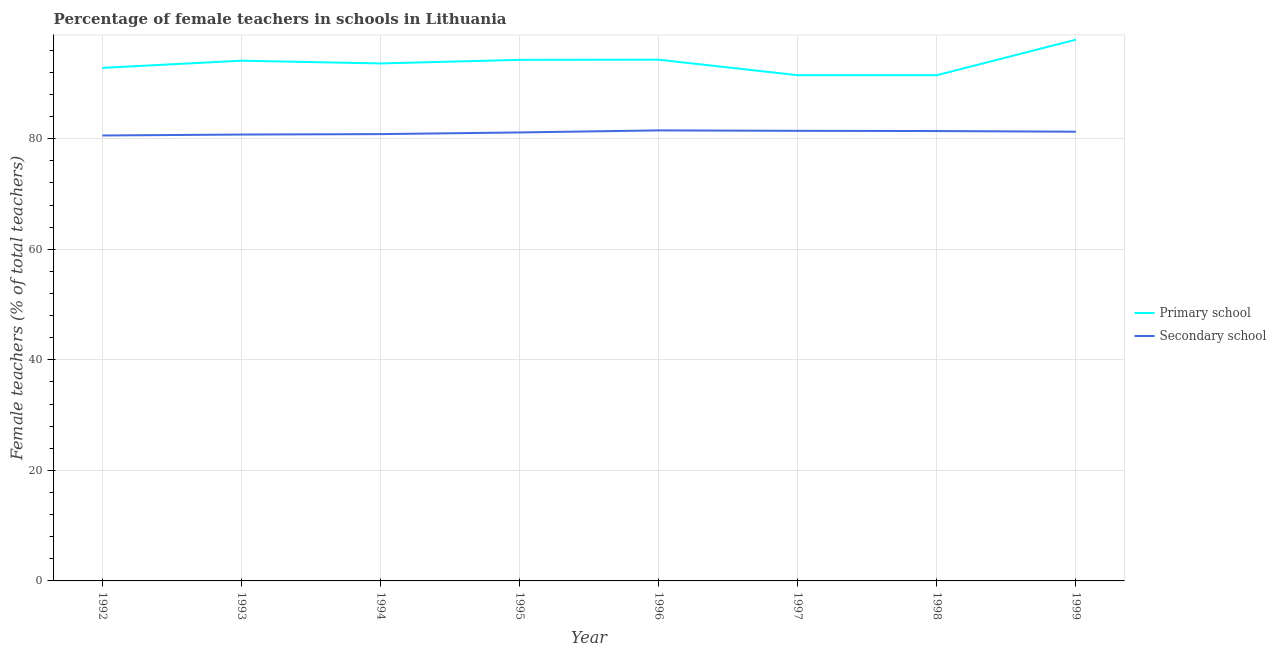How many different coloured lines are there?
Make the answer very short. 2. What is the percentage of female teachers in primary schools in 1994?
Provide a short and direct response. 93.61. Across all years, what is the maximum percentage of female teachers in primary schools?
Offer a terse response. 97.91. Across all years, what is the minimum percentage of female teachers in secondary schools?
Give a very brief answer. 80.58. In which year was the percentage of female teachers in secondary schools maximum?
Make the answer very short. 1996. In which year was the percentage of female teachers in primary schools minimum?
Give a very brief answer. 1997. What is the total percentage of female teachers in primary schools in the graph?
Keep it short and to the point. 749.98. What is the difference between the percentage of female teachers in primary schools in 1996 and that in 1998?
Offer a very short reply. 2.8. What is the difference between the percentage of female teachers in secondary schools in 1999 and the percentage of female teachers in primary schools in 1995?
Make the answer very short. -13. What is the average percentage of female teachers in secondary schools per year?
Your answer should be very brief. 81.11. In the year 1994, what is the difference between the percentage of female teachers in primary schools and percentage of female teachers in secondary schools?
Your answer should be compact. 12.78. What is the ratio of the percentage of female teachers in primary schools in 1992 to that in 1999?
Offer a very short reply. 0.95. What is the difference between the highest and the second highest percentage of female teachers in primary schools?
Provide a short and direct response. 3.62. What is the difference between the highest and the lowest percentage of female teachers in secondary schools?
Give a very brief answer. 0.92. Is the sum of the percentage of female teachers in secondary schools in 1992 and 1998 greater than the maximum percentage of female teachers in primary schools across all years?
Your answer should be very brief. Yes. Does the percentage of female teachers in primary schools monotonically increase over the years?
Provide a succinct answer. No. Is the percentage of female teachers in primary schools strictly less than the percentage of female teachers in secondary schools over the years?
Offer a very short reply. No. How many lines are there?
Ensure brevity in your answer.  2. How many years are there in the graph?
Offer a terse response. 8. What is the difference between two consecutive major ticks on the Y-axis?
Give a very brief answer. 20. Are the values on the major ticks of Y-axis written in scientific E-notation?
Give a very brief answer. No. Does the graph contain any zero values?
Your answer should be compact. No. How are the legend labels stacked?
Offer a very short reply. Vertical. What is the title of the graph?
Give a very brief answer. Percentage of female teachers in schools in Lithuania. Does "Export" appear as one of the legend labels in the graph?
Your answer should be compact. No. What is the label or title of the X-axis?
Keep it short and to the point. Year. What is the label or title of the Y-axis?
Keep it short and to the point. Female teachers (% of total teachers). What is the Female teachers (% of total teachers) in Primary school in 1992?
Your response must be concise. 92.81. What is the Female teachers (% of total teachers) of Secondary school in 1992?
Provide a short and direct response. 80.58. What is the Female teachers (% of total teachers) of Primary school in 1993?
Give a very brief answer. 94.11. What is the Female teachers (% of total teachers) in Secondary school in 1993?
Your answer should be compact. 80.75. What is the Female teachers (% of total teachers) in Primary school in 1994?
Ensure brevity in your answer.  93.61. What is the Female teachers (% of total teachers) in Secondary school in 1994?
Give a very brief answer. 80.83. What is the Female teachers (% of total teachers) in Primary school in 1995?
Your answer should be compact. 94.27. What is the Female teachers (% of total teachers) of Secondary school in 1995?
Give a very brief answer. 81.13. What is the Female teachers (% of total teachers) of Primary school in 1996?
Provide a succinct answer. 94.29. What is the Female teachers (% of total teachers) of Secondary school in 1996?
Your answer should be very brief. 81.5. What is the Female teachers (% of total teachers) of Primary school in 1997?
Your answer should be very brief. 91.49. What is the Female teachers (% of total teachers) of Secondary school in 1997?
Provide a short and direct response. 81.42. What is the Female teachers (% of total teachers) in Primary school in 1998?
Your response must be concise. 91.49. What is the Female teachers (% of total teachers) of Secondary school in 1998?
Your answer should be compact. 81.38. What is the Female teachers (% of total teachers) in Primary school in 1999?
Provide a short and direct response. 97.91. What is the Female teachers (% of total teachers) of Secondary school in 1999?
Offer a very short reply. 81.26. Across all years, what is the maximum Female teachers (% of total teachers) of Primary school?
Your answer should be compact. 97.91. Across all years, what is the maximum Female teachers (% of total teachers) in Secondary school?
Ensure brevity in your answer.  81.5. Across all years, what is the minimum Female teachers (% of total teachers) in Primary school?
Provide a short and direct response. 91.49. Across all years, what is the minimum Female teachers (% of total teachers) in Secondary school?
Make the answer very short. 80.58. What is the total Female teachers (% of total teachers) in Primary school in the graph?
Give a very brief answer. 749.98. What is the total Female teachers (% of total teachers) in Secondary school in the graph?
Ensure brevity in your answer.  648.87. What is the difference between the Female teachers (% of total teachers) of Primary school in 1992 and that in 1993?
Keep it short and to the point. -1.3. What is the difference between the Female teachers (% of total teachers) of Secondary school in 1992 and that in 1993?
Keep it short and to the point. -0.17. What is the difference between the Female teachers (% of total teachers) of Primary school in 1992 and that in 1994?
Make the answer very short. -0.8. What is the difference between the Female teachers (% of total teachers) in Secondary school in 1992 and that in 1994?
Your answer should be very brief. -0.25. What is the difference between the Female teachers (% of total teachers) in Primary school in 1992 and that in 1995?
Keep it short and to the point. -1.45. What is the difference between the Female teachers (% of total teachers) of Secondary school in 1992 and that in 1995?
Give a very brief answer. -0.55. What is the difference between the Female teachers (% of total teachers) in Primary school in 1992 and that in 1996?
Provide a short and direct response. -1.48. What is the difference between the Female teachers (% of total teachers) in Secondary school in 1992 and that in 1996?
Provide a short and direct response. -0.92. What is the difference between the Female teachers (% of total teachers) of Primary school in 1992 and that in 1997?
Give a very brief answer. 1.32. What is the difference between the Female teachers (% of total teachers) in Secondary school in 1992 and that in 1997?
Keep it short and to the point. -0.84. What is the difference between the Female teachers (% of total teachers) of Primary school in 1992 and that in 1998?
Ensure brevity in your answer.  1.32. What is the difference between the Female teachers (% of total teachers) of Secondary school in 1992 and that in 1998?
Your answer should be very brief. -0.8. What is the difference between the Female teachers (% of total teachers) in Primary school in 1992 and that in 1999?
Offer a very short reply. -5.1. What is the difference between the Female teachers (% of total teachers) of Secondary school in 1992 and that in 1999?
Your answer should be compact. -0.68. What is the difference between the Female teachers (% of total teachers) in Primary school in 1993 and that in 1994?
Provide a short and direct response. 0.5. What is the difference between the Female teachers (% of total teachers) of Secondary school in 1993 and that in 1994?
Your response must be concise. -0.08. What is the difference between the Female teachers (% of total teachers) of Primary school in 1993 and that in 1995?
Give a very brief answer. -0.15. What is the difference between the Female teachers (% of total teachers) of Secondary school in 1993 and that in 1995?
Offer a very short reply. -0.38. What is the difference between the Female teachers (% of total teachers) in Primary school in 1993 and that in 1996?
Offer a terse response. -0.18. What is the difference between the Female teachers (% of total teachers) of Secondary school in 1993 and that in 1996?
Provide a short and direct response. -0.75. What is the difference between the Female teachers (% of total teachers) of Primary school in 1993 and that in 1997?
Keep it short and to the point. 2.63. What is the difference between the Female teachers (% of total teachers) of Secondary school in 1993 and that in 1997?
Your answer should be compact. -0.67. What is the difference between the Female teachers (% of total teachers) of Primary school in 1993 and that in 1998?
Your answer should be compact. 2.63. What is the difference between the Female teachers (% of total teachers) in Secondary school in 1993 and that in 1998?
Provide a short and direct response. -0.63. What is the difference between the Female teachers (% of total teachers) of Primary school in 1993 and that in 1999?
Ensure brevity in your answer.  -3.8. What is the difference between the Female teachers (% of total teachers) of Secondary school in 1993 and that in 1999?
Offer a terse response. -0.51. What is the difference between the Female teachers (% of total teachers) in Primary school in 1994 and that in 1995?
Keep it short and to the point. -0.65. What is the difference between the Female teachers (% of total teachers) of Secondary school in 1994 and that in 1995?
Give a very brief answer. -0.3. What is the difference between the Female teachers (% of total teachers) of Primary school in 1994 and that in 1996?
Your answer should be very brief. -0.68. What is the difference between the Female teachers (% of total teachers) in Secondary school in 1994 and that in 1996?
Your answer should be compact. -0.67. What is the difference between the Female teachers (% of total teachers) of Primary school in 1994 and that in 1997?
Provide a short and direct response. 2.12. What is the difference between the Female teachers (% of total teachers) in Secondary school in 1994 and that in 1997?
Make the answer very short. -0.59. What is the difference between the Female teachers (% of total teachers) in Primary school in 1994 and that in 1998?
Make the answer very short. 2.12. What is the difference between the Female teachers (% of total teachers) in Secondary school in 1994 and that in 1998?
Provide a short and direct response. -0.56. What is the difference between the Female teachers (% of total teachers) of Primary school in 1994 and that in 1999?
Your answer should be very brief. -4.3. What is the difference between the Female teachers (% of total teachers) in Secondary school in 1994 and that in 1999?
Your answer should be very brief. -0.44. What is the difference between the Female teachers (% of total teachers) of Primary school in 1995 and that in 1996?
Offer a very short reply. -0.03. What is the difference between the Female teachers (% of total teachers) in Secondary school in 1995 and that in 1996?
Keep it short and to the point. -0.37. What is the difference between the Female teachers (% of total teachers) in Primary school in 1995 and that in 1997?
Offer a very short reply. 2.78. What is the difference between the Female teachers (% of total teachers) of Secondary school in 1995 and that in 1997?
Your answer should be very brief. -0.29. What is the difference between the Female teachers (% of total teachers) of Primary school in 1995 and that in 1998?
Provide a succinct answer. 2.78. What is the difference between the Female teachers (% of total teachers) in Secondary school in 1995 and that in 1998?
Provide a short and direct response. -0.25. What is the difference between the Female teachers (% of total teachers) of Primary school in 1995 and that in 1999?
Keep it short and to the point. -3.65. What is the difference between the Female teachers (% of total teachers) in Secondary school in 1995 and that in 1999?
Your answer should be very brief. -0.13. What is the difference between the Female teachers (% of total teachers) in Primary school in 1996 and that in 1997?
Provide a short and direct response. 2.8. What is the difference between the Female teachers (% of total teachers) of Secondary school in 1996 and that in 1997?
Give a very brief answer. 0.08. What is the difference between the Female teachers (% of total teachers) in Primary school in 1996 and that in 1998?
Provide a short and direct response. 2.8. What is the difference between the Female teachers (% of total teachers) in Secondary school in 1996 and that in 1998?
Your response must be concise. 0.12. What is the difference between the Female teachers (% of total teachers) in Primary school in 1996 and that in 1999?
Provide a short and direct response. -3.62. What is the difference between the Female teachers (% of total teachers) of Secondary school in 1996 and that in 1999?
Offer a terse response. 0.24. What is the difference between the Female teachers (% of total teachers) of Primary school in 1997 and that in 1998?
Offer a terse response. -0. What is the difference between the Female teachers (% of total teachers) in Secondary school in 1997 and that in 1998?
Ensure brevity in your answer.  0.04. What is the difference between the Female teachers (% of total teachers) of Primary school in 1997 and that in 1999?
Keep it short and to the point. -6.43. What is the difference between the Female teachers (% of total teachers) in Secondary school in 1997 and that in 1999?
Your response must be concise. 0.16. What is the difference between the Female teachers (% of total teachers) of Primary school in 1998 and that in 1999?
Keep it short and to the point. -6.43. What is the difference between the Female teachers (% of total teachers) in Secondary school in 1998 and that in 1999?
Your answer should be very brief. 0.12. What is the difference between the Female teachers (% of total teachers) of Primary school in 1992 and the Female teachers (% of total teachers) of Secondary school in 1993?
Ensure brevity in your answer.  12.06. What is the difference between the Female teachers (% of total teachers) in Primary school in 1992 and the Female teachers (% of total teachers) in Secondary school in 1994?
Provide a succinct answer. 11.98. What is the difference between the Female teachers (% of total teachers) of Primary school in 1992 and the Female teachers (% of total teachers) of Secondary school in 1995?
Keep it short and to the point. 11.68. What is the difference between the Female teachers (% of total teachers) of Primary school in 1992 and the Female teachers (% of total teachers) of Secondary school in 1996?
Keep it short and to the point. 11.31. What is the difference between the Female teachers (% of total teachers) in Primary school in 1992 and the Female teachers (% of total teachers) in Secondary school in 1997?
Provide a short and direct response. 11.39. What is the difference between the Female teachers (% of total teachers) in Primary school in 1992 and the Female teachers (% of total teachers) in Secondary school in 1998?
Provide a succinct answer. 11.43. What is the difference between the Female teachers (% of total teachers) of Primary school in 1992 and the Female teachers (% of total teachers) of Secondary school in 1999?
Provide a short and direct response. 11.55. What is the difference between the Female teachers (% of total teachers) of Primary school in 1993 and the Female teachers (% of total teachers) of Secondary school in 1994?
Your response must be concise. 13.28. What is the difference between the Female teachers (% of total teachers) in Primary school in 1993 and the Female teachers (% of total teachers) in Secondary school in 1995?
Ensure brevity in your answer.  12.98. What is the difference between the Female teachers (% of total teachers) in Primary school in 1993 and the Female teachers (% of total teachers) in Secondary school in 1996?
Keep it short and to the point. 12.61. What is the difference between the Female teachers (% of total teachers) of Primary school in 1993 and the Female teachers (% of total teachers) of Secondary school in 1997?
Make the answer very short. 12.69. What is the difference between the Female teachers (% of total teachers) of Primary school in 1993 and the Female teachers (% of total teachers) of Secondary school in 1998?
Provide a succinct answer. 12.73. What is the difference between the Female teachers (% of total teachers) of Primary school in 1993 and the Female teachers (% of total teachers) of Secondary school in 1999?
Give a very brief answer. 12.85. What is the difference between the Female teachers (% of total teachers) in Primary school in 1994 and the Female teachers (% of total teachers) in Secondary school in 1995?
Offer a very short reply. 12.48. What is the difference between the Female teachers (% of total teachers) in Primary school in 1994 and the Female teachers (% of total teachers) in Secondary school in 1996?
Ensure brevity in your answer.  12.11. What is the difference between the Female teachers (% of total teachers) of Primary school in 1994 and the Female teachers (% of total teachers) of Secondary school in 1997?
Provide a short and direct response. 12.19. What is the difference between the Female teachers (% of total teachers) of Primary school in 1994 and the Female teachers (% of total teachers) of Secondary school in 1998?
Offer a terse response. 12.23. What is the difference between the Female teachers (% of total teachers) in Primary school in 1994 and the Female teachers (% of total teachers) in Secondary school in 1999?
Provide a short and direct response. 12.35. What is the difference between the Female teachers (% of total teachers) of Primary school in 1995 and the Female teachers (% of total teachers) of Secondary school in 1996?
Provide a short and direct response. 12.76. What is the difference between the Female teachers (% of total teachers) in Primary school in 1995 and the Female teachers (% of total teachers) in Secondary school in 1997?
Make the answer very short. 12.84. What is the difference between the Female teachers (% of total teachers) in Primary school in 1995 and the Female teachers (% of total teachers) in Secondary school in 1998?
Your answer should be compact. 12.88. What is the difference between the Female teachers (% of total teachers) of Primary school in 1995 and the Female teachers (% of total teachers) of Secondary school in 1999?
Your answer should be compact. 13. What is the difference between the Female teachers (% of total teachers) of Primary school in 1996 and the Female teachers (% of total teachers) of Secondary school in 1997?
Your answer should be very brief. 12.87. What is the difference between the Female teachers (% of total teachers) in Primary school in 1996 and the Female teachers (% of total teachers) in Secondary school in 1998?
Give a very brief answer. 12.91. What is the difference between the Female teachers (% of total teachers) in Primary school in 1996 and the Female teachers (% of total teachers) in Secondary school in 1999?
Your answer should be compact. 13.03. What is the difference between the Female teachers (% of total teachers) of Primary school in 1997 and the Female teachers (% of total teachers) of Secondary school in 1998?
Ensure brevity in your answer.  10.1. What is the difference between the Female teachers (% of total teachers) in Primary school in 1997 and the Female teachers (% of total teachers) in Secondary school in 1999?
Make the answer very short. 10.22. What is the difference between the Female teachers (% of total teachers) in Primary school in 1998 and the Female teachers (% of total teachers) in Secondary school in 1999?
Ensure brevity in your answer.  10.22. What is the average Female teachers (% of total teachers) of Primary school per year?
Provide a succinct answer. 93.75. What is the average Female teachers (% of total teachers) in Secondary school per year?
Give a very brief answer. 81.11. In the year 1992, what is the difference between the Female teachers (% of total teachers) in Primary school and Female teachers (% of total teachers) in Secondary school?
Ensure brevity in your answer.  12.23. In the year 1993, what is the difference between the Female teachers (% of total teachers) of Primary school and Female teachers (% of total teachers) of Secondary school?
Ensure brevity in your answer.  13.36. In the year 1994, what is the difference between the Female teachers (% of total teachers) in Primary school and Female teachers (% of total teachers) in Secondary school?
Provide a short and direct response. 12.78. In the year 1995, what is the difference between the Female teachers (% of total teachers) of Primary school and Female teachers (% of total teachers) of Secondary school?
Offer a very short reply. 13.13. In the year 1996, what is the difference between the Female teachers (% of total teachers) in Primary school and Female teachers (% of total teachers) in Secondary school?
Your answer should be very brief. 12.79. In the year 1997, what is the difference between the Female teachers (% of total teachers) of Primary school and Female teachers (% of total teachers) of Secondary school?
Your answer should be compact. 10.06. In the year 1998, what is the difference between the Female teachers (% of total teachers) in Primary school and Female teachers (% of total teachers) in Secondary school?
Ensure brevity in your answer.  10.1. In the year 1999, what is the difference between the Female teachers (% of total teachers) of Primary school and Female teachers (% of total teachers) of Secondary school?
Provide a succinct answer. 16.65. What is the ratio of the Female teachers (% of total teachers) of Primary school in 1992 to that in 1993?
Give a very brief answer. 0.99. What is the ratio of the Female teachers (% of total teachers) of Secondary school in 1992 to that in 1994?
Keep it short and to the point. 1. What is the ratio of the Female teachers (% of total teachers) of Primary school in 1992 to that in 1995?
Provide a succinct answer. 0.98. What is the ratio of the Female teachers (% of total teachers) of Primary school in 1992 to that in 1996?
Provide a short and direct response. 0.98. What is the ratio of the Female teachers (% of total teachers) in Secondary school in 1992 to that in 1996?
Offer a very short reply. 0.99. What is the ratio of the Female teachers (% of total teachers) of Primary school in 1992 to that in 1997?
Provide a short and direct response. 1.01. What is the ratio of the Female teachers (% of total teachers) of Secondary school in 1992 to that in 1997?
Provide a succinct answer. 0.99. What is the ratio of the Female teachers (% of total teachers) in Primary school in 1992 to that in 1998?
Your response must be concise. 1.01. What is the ratio of the Female teachers (% of total teachers) in Secondary school in 1992 to that in 1998?
Your response must be concise. 0.99. What is the ratio of the Female teachers (% of total teachers) in Primary school in 1992 to that in 1999?
Your answer should be very brief. 0.95. What is the ratio of the Female teachers (% of total teachers) of Primary school in 1993 to that in 1994?
Make the answer very short. 1.01. What is the ratio of the Female teachers (% of total teachers) of Secondary school in 1993 to that in 1994?
Provide a succinct answer. 1. What is the ratio of the Female teachers (% of total teachers) of Primary school in 1993 to that in 1995?
Your answer should be compact. 1. What is the ratio of the Female teachers (% of total teachers) of Primary school in 1993 to that in 1997?
Ensure brevity in your answer.  1.03. What is the ratio of the Female teachers (% of total teachers) of Primary school in 1993 to that in 1998?
Make the answer very short. 1.03. What is the ratio of the Female teachers (% of total teachers) in Primary school in 1993 to that in 1999?
Your answer should be very brief. 0.96. What is the ratio of the Female teachers (% of total teachers) of Primary school in 1994 to that in 1995?
Your answer should be very brief. 0.99. What is the ratio of the Female teachers (% of total teachers) in Secondary school in 1994 to that in 1996?
Your answer should be very brief. 0.99. What is the ratio of the Female teachers (% of total teachers) in Primary school in 1994 to that in 1997?
Offer a very short reply. 1.02. What is the ratio of the Female teachers (% of total teachers) in Primary school in 1994 to that in 1998?
Provide a succinct answer. 1.02. What is the ratio of the Female teachers (% of total teachers) of Primary school in 1994 to that in 1999?
Your response must be concise. 0.96. What is the ratio of the Female teachers (% of total teachers) of Primary school in 1995 to that in 1996?
Your answer should be very brief. 1. What is the ratio of the Female teachers (% of total teachers) in Primary school in 1995 to that in 1997?
Offer a terse response. 1.03. What is the ratio of the Female teachers (% of total teachers) of Secondary school in 1995 to that in 1997?
Offer a very short reply. 1. What is the ratio of the Female teachers (% of total teachers) in Primary school in 1995 to that in 1998?
Ensure brevity in your answer.  1.03. What is the ratio of the Female teachers (% of total teachers) of Secondary school in 1995 to that in 1998?
Make the answer very short. 1. What is the ratio of the Female teachers (% of total teachers) in Primary school in 1995 to that in 1999?
Provide a succinct answer. 0.96. What is the ratio of the Female teachers (% of total teachers) of Primary school in 1996 to that in 1997?
Provide a short and direct response. 1.03. What is the ratio of the Female teachers (% of total teachers) in Primary school in 1996 to that in 1998?
Ensure brevity in your answer.  1.03. What is the ratio of the Female teachers (% of total teachers) of Secondary school in 1996 to that in 1998?
Make the answer very short. 1. What is the ratio of the Female teachers (% of total teachers) of Primary school in 1997 to that in 1999?
Offer a terse response. 0.93. What is the ratio of the Female teachers (% of total teachers) in Secondary school in 1997 to that in 1999?
Your response must be concise. 1. What is the ratio of the Female teachers (% of total teachers) in Primary school in 1998 to that in 1999?
Provide a short and direct response. 0.93. What is the ratio of the Female teachers (% of total teachers) of Secondary school in 1998 to that in 1999?
Your answer should be compact. 1. What is the difference between the highest and the second highest Female teachers (% of total teachers) of Primary school?
Provide a short and direct response. 3.62. What is the difference between the highest and the second highest Female teachers (% of total teachers) of Secondary school?
Give a very brief answer. 0.08. What is the difference between the highest and the lowest Female teachers (% of total teachers) of Primary school?
Your response must be concise. 6.43. What is the difference between the highest and the lowest Female teachers (% of total teachers) of Secondary school?
Your response must be concise. 0.92. 